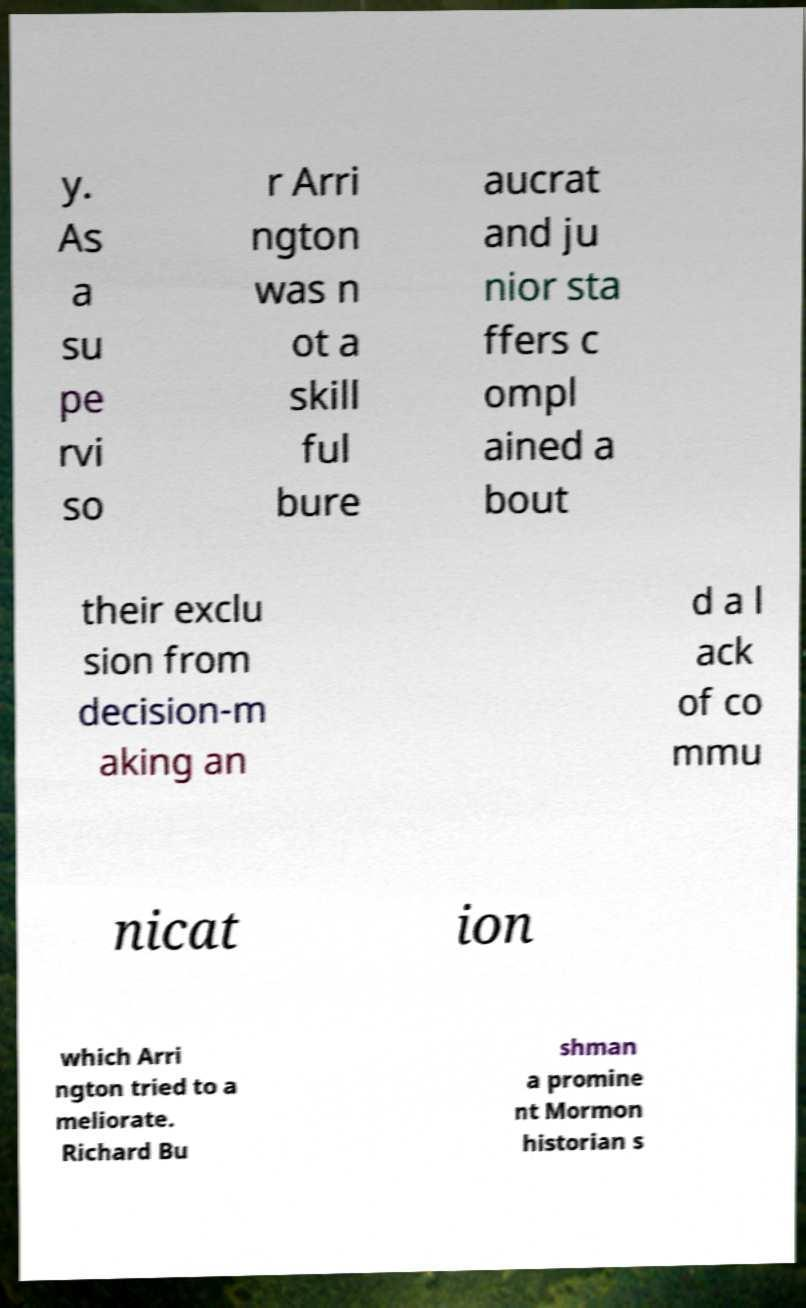Could you extract and type out the text from this image? y. As a su pe rvi so r Arri ngton was n ot a skill ful bure aucrat and ju nior sta ffers c ompl ained a bout their exclu sion from decision-m aking an d a l ack of co mmu nicat ion which Arri ngton tried to a meliorate. Richard Bu shman a promine nt Mormon historian s 